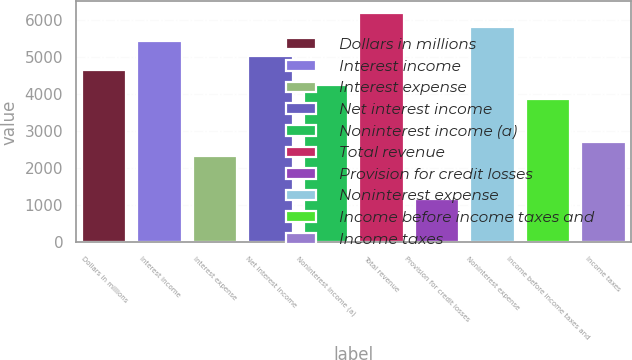Convert chart to OTSL. <chart><loc_0><loc_0><loc_500><loc_500><bar_chart><fcel>Dollars in millions<fcel>Interest income<fcel>Interest expense<fcel>Net interest income<fcel>Noninterest income (a)<fcel>Total revenue<fcel>Provision for credit losses<fcel>Noninterest expense<fcel>Income before income taxes and<fcel>Income taxes<nl><fcel>4638.8<fcel>5411.62<fcel>2320.34<fcel>5025.21<fcel>4252.39<fcel>6184.44<fcel>1161.11<fcel>5798.03<fcel>3865.98<fcel>2706.75<nl></chart> 